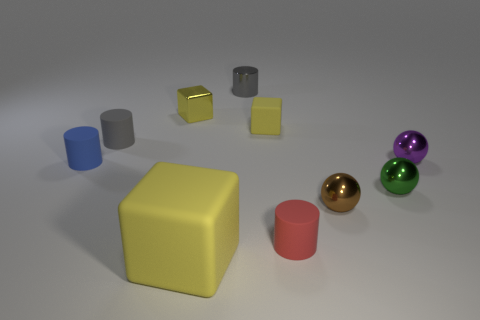Can you tell me about the lighting in this scene and how it affects the appearance of the objects? Certainly! The image employs soft, diffuse lighting that casts gentle shadows on the ground, contributing to a calm and balanced atmosphere. The lighting highlights the luster of the glossy objects and accentuates their colors, while helping to define the three-dimensionality of the shapes by creating light and dark areas that suggest volume and depth. 